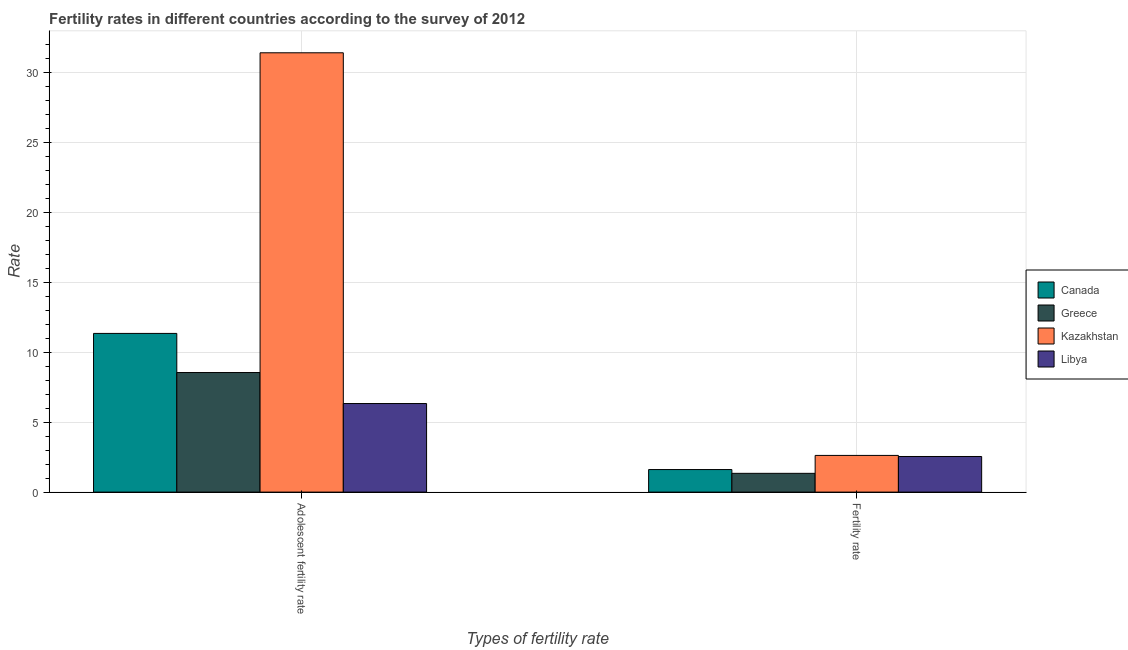How many different coloured bars are there?
Make the answer very short. 4. How many groups of bars are there?
Provide a succinct answer. 2. How many bars are there on the 1st tick from the left?
Provide a short and direct response. 4. How many bars are there on the 2nd tick from the right?
Make the answer very short. 4. What is the label of the 1st group of bars from the left?
Your answer should be compact. Adolescent fertility rate. What is the fertility rate in Greece?
Make the answer very short. 1.34. Across all countries, what is the maximum adolescent fertility rate?
Offer a very short reply. 31.38. Across all countries, what is the minimum adolescent fertility rate?
Provide a short and direct response. 6.33. In which country was the fertility rate maximum?
Your response must be concise. Kazakhstan. In which country was the adolescent fertility rate minimum?
Your answer should be compact. Libya. What is the total adolescent fertility rate in the graph?
Your response must be concise. 57.57. What is the difference between the adolescent fertility rate in Greece and that in Libya?
Provide a short and direct response. 2.21. What is the difference between the fertility rate in Greece and the adolescent fertility rate in Canada?
Ensure brevity in your answer.  -9.99. What is the average fertility rate per country?
Offer a terse response. 2.03. What is the difference between the fertility rate and adolescent fertility rate in Kazakhstan?
Give a very brief answer. -28.76. In how many countries, is the fertility rate greater than 28 ?
Offer a very short reply. 0. What is the ratio of the adolescent fertility rate in Greece to that in Libya?
Ensure brevity in your answer.  1.35. In how many countries, is the adolescent fertility rate greater than the average adolescent fertility rate taken over all countries?
Ensure brevity in your answer.  1. How many bars are there?
Offer a terse response. 8. Are all the bars in the graph horizontal?
Offer a terse response. No. Are the values on the major ticks of Y-axis written in scientific E-notation?
Make the answer very short. No. Does the graph contain grids?
Provide a succinct answer. Yes. Where does the legend appear in the graph?
Your response must be concise. Center right. What is the title of the graph?
Keep it short and to the point. Fertility rates in different countries according to the survey of 2012. What is the label or title of the X-axis?
Provide a succinct answer. Types of fertility rate. What is the label or title of the Y-axis?
Keep it short and to the point. Rate. What is the Rate of Canada in Adolescent fertility rate?
Your answer should be compact. 11.33. What is the Rate in Greece in Adolescent fertility rate?
Make the answer very short. 8.54. What is the Rate of Kazakhstan in Adolescent fertility rate?
Your answer should be very brief. 31.38. What is the Rate of Libya in Adolescent fertility rate?
Offer a terse response. 6.33. What is the Rate of Canada in Fertility rate?
Give a very brief answer. 1.61. What is the Rate in Greece in Fertility rate?
Offer a terse response. 1.34. What is the Rate of Kazakhstan in Fertility rate?
Offer a terse response. 2.62. What is the Rate in Libya in Fertility rate?
Your response must be concise. 2.54. Across all Types of fertility rate, what is the maximum Rate in Canada?
Make the answer very short. 11.33. Across all Types of fertility rate, what is the maximum Rate in Greece?
Offer a terse response. 8.54. Across all Types of fertility rate, what is the maximum Rate of Kazakhstan?
Keep it short and to the point. 31.38. Across all Types of fertility rate, what is the maximum Rate of Libya?
Keep it short and to the point. 6.33. Across all Types of fertility rate, what is the minimum Rate in Canada?
Offer a terse response. 1.61. Across all Types of fertility rate, what is the minimum Rate in Greece?
Offer a very short reply. 1.34. Across all Types of fertility rate, what is the minimum Rate in Kazakhstan?
Your answer should be very brief. 2.62. Across all Types of fertility rate, what is the minimum Rate of Libya?
Your answer should be very brief. 2.54. What is the total Rate in Canada in the graph?
Ensure brevity in your answer.  12.94. What is the total Rate of Greece in the graph?
Your response must be concise. 9.88. What is the total Rate in Kazakhstan in the graph?
Your answer should be compact. 34. What is the total Rate in Libya in the graph?
Provide a succinct answer. 8.87. What is the difference between the Rate of Canada in Adolescent fertility rate and that in Fertility rate?
Offer a terse response. 9.72. What is the difference between the Rate of Greece in Adolescent fertility rate and that in Fertility rate?
Offer a terse response. 7.2. What is the difference between the Rate of Kazakhstan in Adolescent fertility rate and that in Fertility rate?
Provide a short and direct response. 28.76. What is the difference between the Rate in Libya in Adolescent fertility rate and that in Fertility rate?
Offer a terse response. 3.78. What is the difference between the Rate of Canada in Adolescent fertility rate and the Rate of Greece in Fertility rate?
Your response must be concise. 9.99. What is the difference between the Rate in Canada in Adolescent fertility rate and the Rate in Kazakhstan in Fertility rate?
Make the answer very short. 8.71. What is the difference between the Rate of Canada in Adolescent fertility rate and the Rate of Libya in Fertility rate?
Give a very brief answer. 8.79. What is the difference between the Rate in Greece in Adolescent fertility rate and the Rate in Kazakhstan in Fertility rate?
Your answer should be compact. 5.92. What is the difference between the Rate of Greece in Adolescent fertility rate and the Rate of Libya in Fertility rate?
Offer a terse response. 6. What is the difference between the Rate in Kazakhstan in Adolescent fertility rate and the Rate in Libya in Fertility rate?
Offer a terse response. 28.83. What is the average Rate of Canada per Types of fertility rate?
Offer a very short reply. 6.47. What is the average Rate of Greece per Types of fertility rate?
Ensure brevity in your answer.  4.94. What is the average Rate of Kazakhstan per Types of fertility rate?
Give a very brief answer. 17. What is the average Rate in Libya per Types of fertility rate?
Make the answer very short. 4.43. What is the difference between the Rate in Canada and Rate in Greece in Adolescent fertility rate?
Your response must be concise. 2.79. What is the difference between the Rate of Canada and Rate of Kazakhstan in Adolescent fertility rate?
Keep it short and to the point. -20.04. What is the difference between the Rate of Canada and Rate of Libya in Adolescent fertility rate?
Give a very brief answer. 5.01. What is the difference between the Rate in Greece and Rate in Kazakhstan in Adolescent fertility rate?
Provide a short and direct response. -22.84. What is the difference between the Rate of Greece and Rate of Libya in Adolescent fertility rate?
Your response must be concise. 2.21. What is the difference between the Rate of Kazakhstan and Rate of Libya in Adolescent fertility rate?
Give a very brief answer. 25.05. What is the difference between the Rate in Canada and Rate in Greece in Fertility rate?
Your response must be concise. 0.27. What is the difference between the Rate of Canada and Rate of Kazakhstan in Fertility rate?
Your response must be concise. -1.01. What is the difference between the Rate in Canada and Rate in Libya in Fertility rate?
Keep it short and to the point. -0.93. What is the difference between the Rate of Greece and Rate of Kazakhstan in Fertility rate?
Your response must be concise. -1.28. What is the difference between the Rate of Greece and Rate of Libya in Fertility rate?
Provide a succinct answer. -1.2. What is the difference between the Rate in Kazakhstan and Rate in Libya in Fertility rate?
Ensure brevity in your answer.  0.08. What is the ratio of the Rate in Canada in Adolescent fertility rate to that in Fertility rate?
Offer a terse response. 7.04. What is the ratio of the Rate of Greece in Adolescent fertility rate to that in Fertility rate?
Give a very brief answer. 6.37. What is the ratio of the Rate in Kazakhstan in Adolescent fertility rate to that in Fertility rate?
Provide a short and direct response. 11.98. What is the ratio of the Rate of Libya in Adolescent fertility rate to that in Fertility rate?
Ensure brevity in your answer.  2.49. What is the difference between the highest and the second highest Rate of Canada?
Make the answer very short. 9.72. What is the difference between the highest and the second highest Rate in Greece?
Give a very brief answer. 7.2. What is the difference between the highest and the second highest Rate of Kazakhstan?
Offer a terse response. 28.76. What is the difference between the highest and the second highest Rate in Libya?
Make the answer very short. 3.78. What is the difference between the highest and the lowest Rate of Canada?
Your response must be concise. 9.72. What is the difference between the highest and the lowest Rate of Greece?
Your answer should be very brief. 7.2. What is the difference between the highest and the lowest Rate in Kazakhstan?
Ensure brevity in your answer.  28.76. What is the difference between the highest and the lowest Rate in Libya?
Keep it short and to the point. 3.78. 